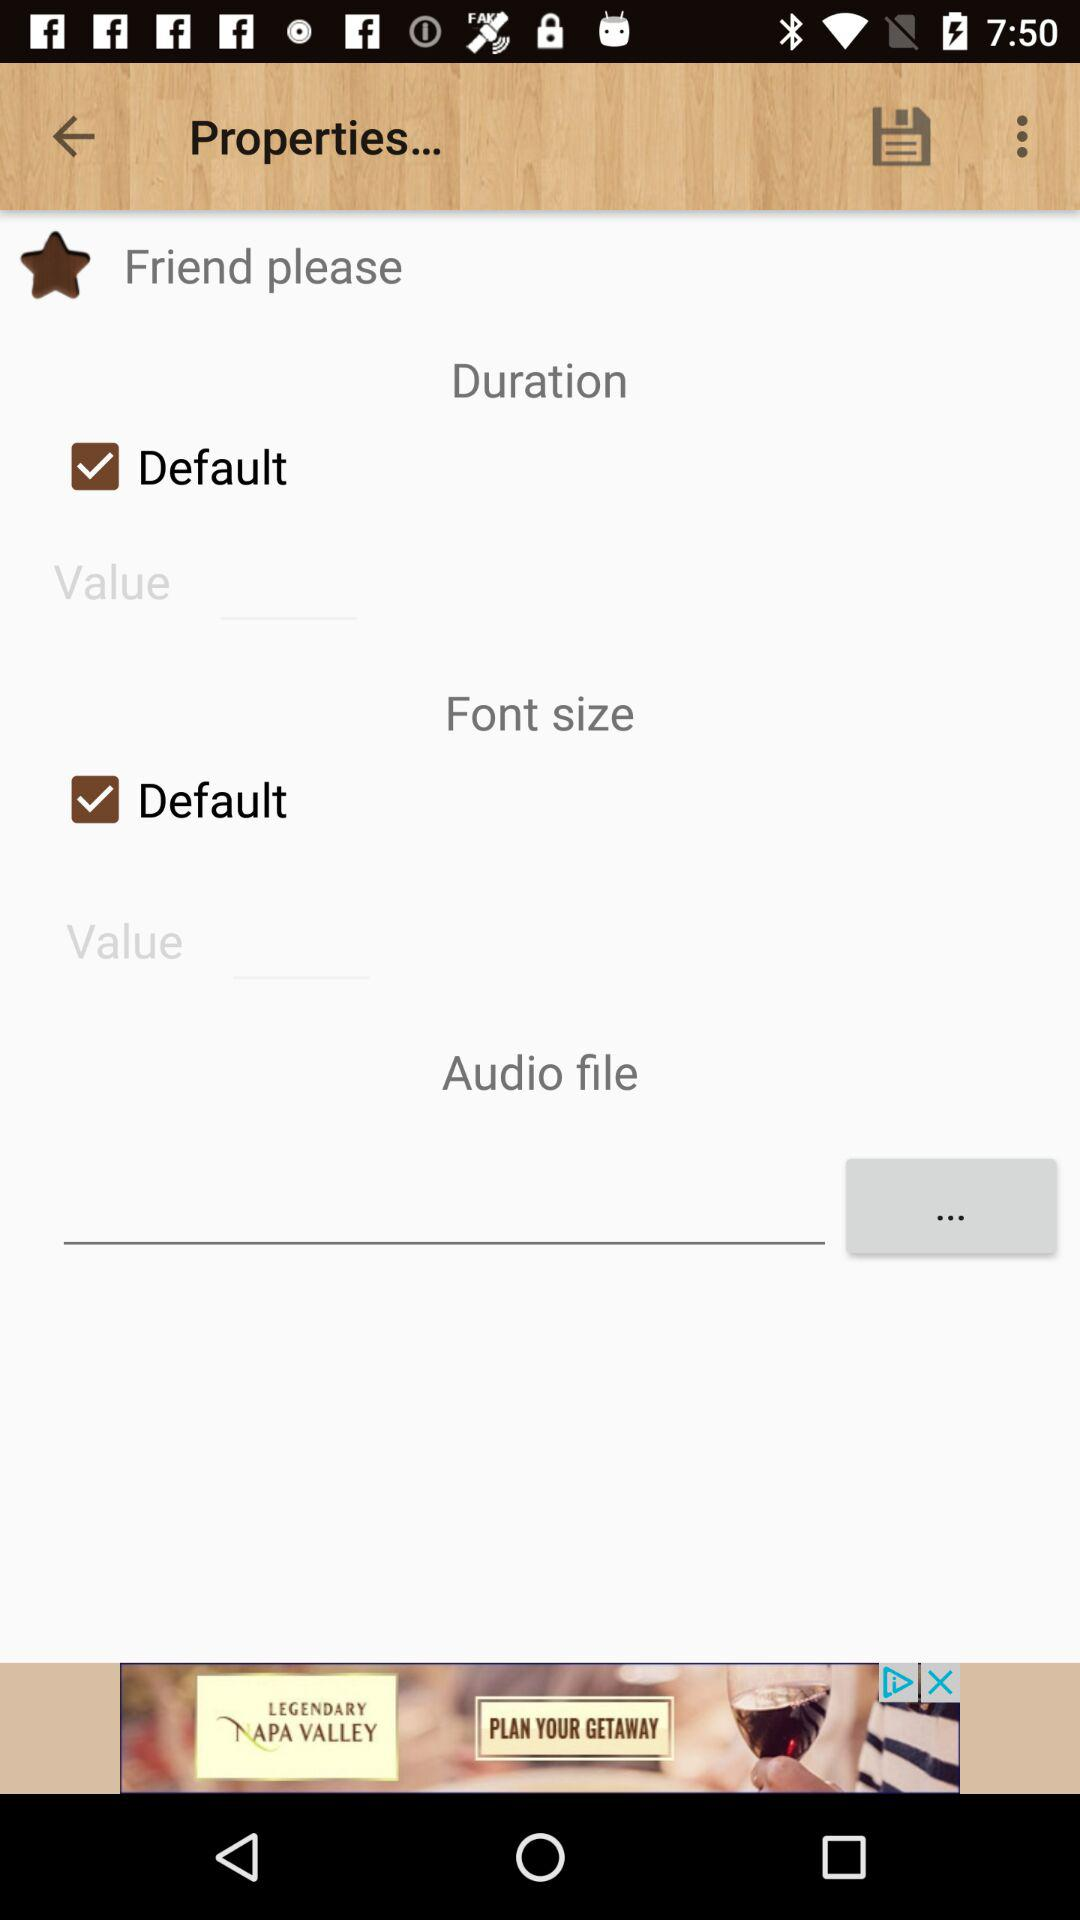What is the status of "Default" duration? The status is "on". 